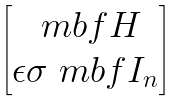<formula> <loc_0><loc_0><loc_500><loc_500>\begin{bmatrix} \ m b f { H } \\ \epsilon \sigma \ m b f { I } _ { n } \end{bmatrix}</formula> 